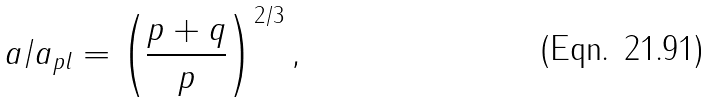<formula> <loc_0><loc_0><loc_500><loc_500>a / a _ { p l } = \left ( \frac { p + q } { p } \right ) ^ { 2 / 3 } ,</formula> 